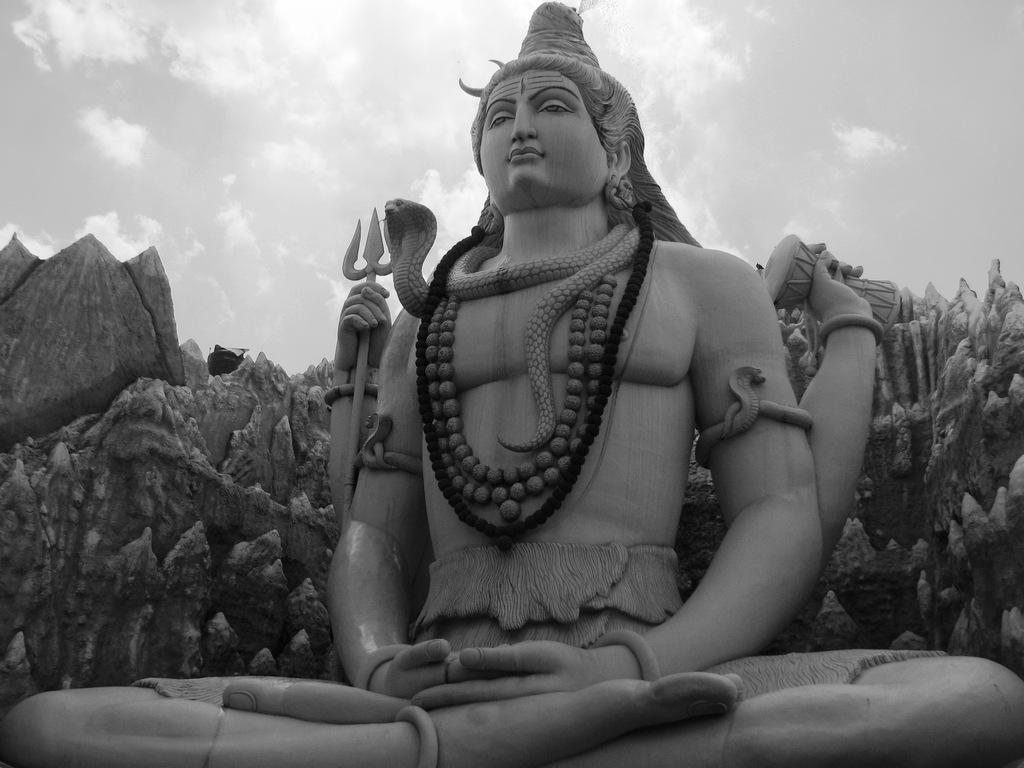What can be seen in the sky in the image? The sky is visible in the image, but no specific details about the sky are provided. What is the main subject of the image? There is a statue of Lord Shiva in the image. What type of wood is used to make the card in the image? There is no card present in the image, and therefore no wood or material can be identified. How does the statue of Lord Shiva express anger in the image? The statue of Lord Shiva is a static object and does not express emotions like anger in the image. 